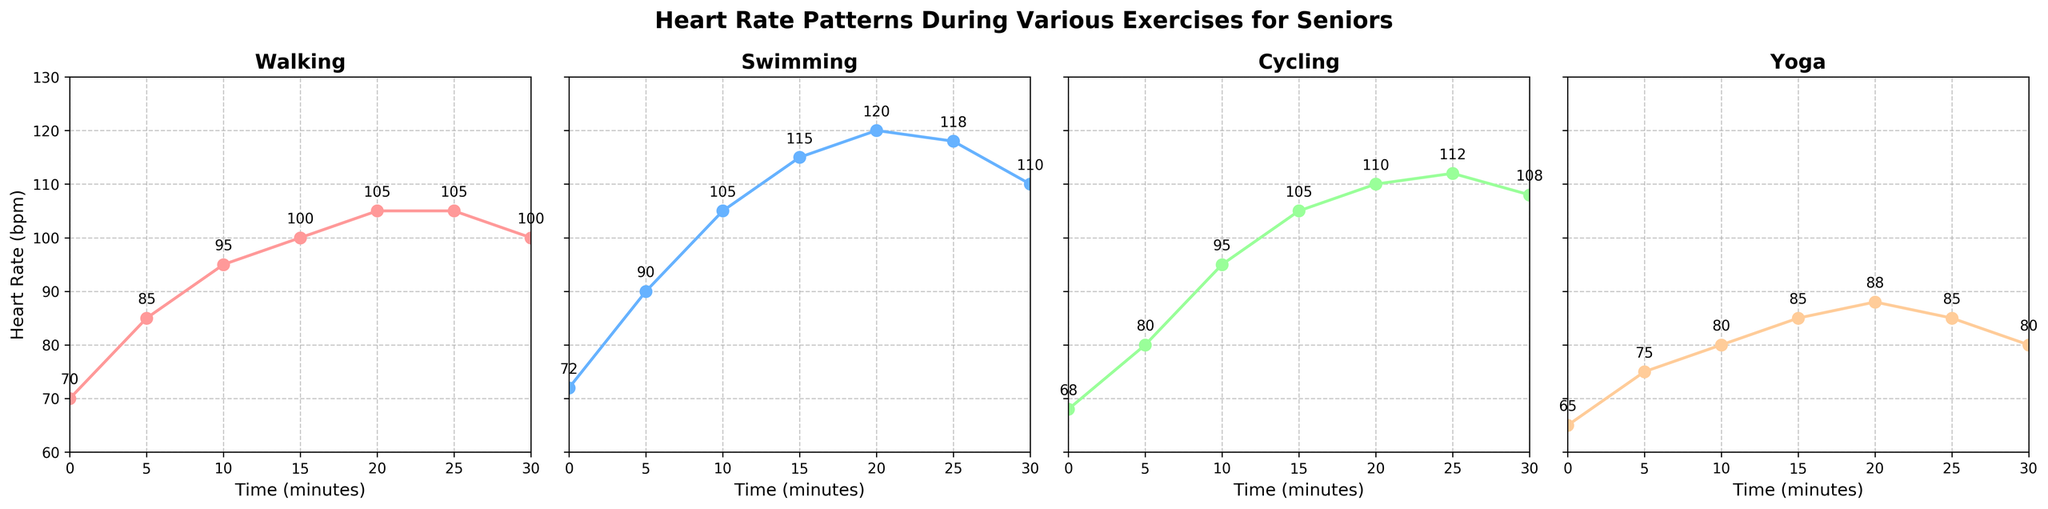What is the highest heart rate recorded during swimming? The plot for swimming shows that the heart rate peaks at 120 bpm at the 20-minute mark.
Answer: 120 bpm How does the heart rate change for yoga from the start to the 15-minute mark? At the start of yoga, the heart rate is 65 bpm. At the 15-minute mark, it reaches 85 bpm. The heart rate increases by 20 bpm.
Answer: Increases by 20 bpm Which exercise shows a steady heart rate after reaching a peak? The heart rate during walking peaks at 105 bpm at the 20-minute mark and remains steady at 105 bpm until the 25-minute mark before it starts to decline.
Answer: Walking Compare the heart rate at the 10-minute mark between walking and cycling. Which is higher? By how much? At the 10-minute mark, the heart rate for walking is 95 bpm, and for cycling, it is also 95 bpm. There is no difference.
Answer: Equal; 0 bpm During which exercise session does the heart rate drop from its peak within the 30-minute period? For swimming, the heart rate peaks at 120 bpm at 20 minutes and then drops to 110 bpm at 30 minutes.
Answer: Swimming Which exercise has the lowest initial heart rate, and what is the value? The plot indicates that cycling has the lowest initial heart rate at 68 bpm.
Answer: Cycling; 68 bpm What is the average heart rate for walking over the 30-minute session? The heart rates at each time interval for walking are [70, 85, 95, 100, 105, 105, 100]. The sum is 660 bpm over 7 points, giving an average of 660/7 ≈ 94.3 bpm.
Answer: 94.3 bpm Which exercise shows the highest overall change in heart rate from start to finish? Swimming starts at 72 bpm and ends at 110 bpm, a change of 38 bpm. Walking, yoga, and cycling have smaller overall changes.
Answer: Swimming Between swimming and cycling, which exercise has the higher heart rate at the 25-minute mark? At the 25-minute mark, swimming has a heart rate of 118 bpm, while cycling has a heart rate of 112 bpm.
Answer: Swimming During which exercise does the heart rate decline between the 25-minute and 30-minute marks? For both yoga and swimming, the heart rates at the 25-minute and 30-minute marks are [85, 80] and [118, 110] respectively. Both show a decline.
Answer: Yoga and swimming 